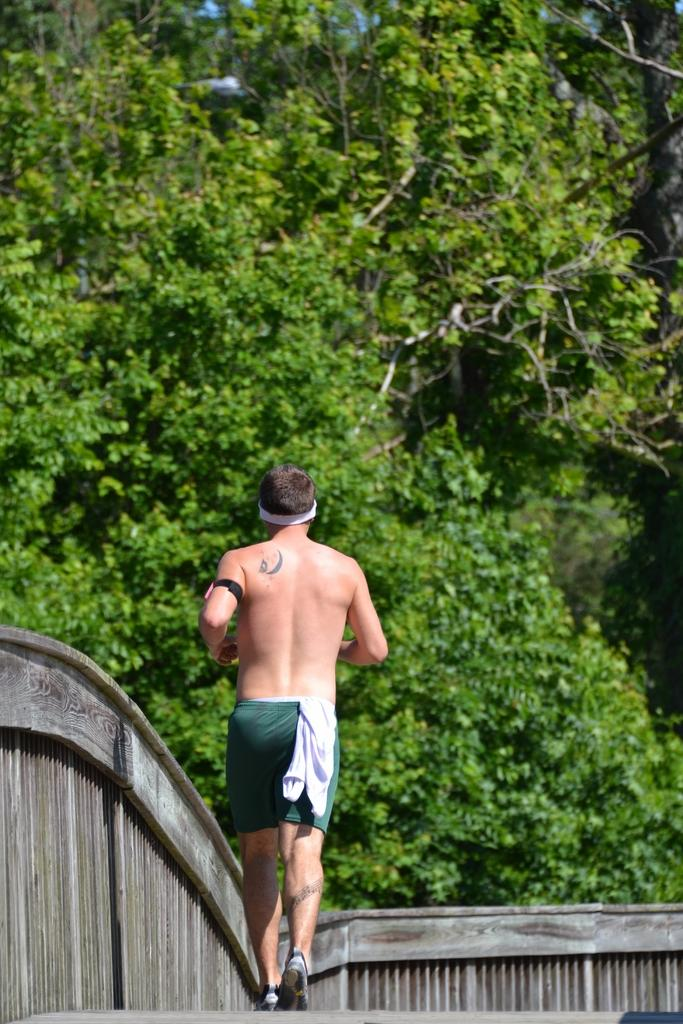What is the main subject of the image? There is a man in the image. What is the man doing in the image? The man is running. On what surface is the man running? The man is running on a wooden plank. What can be seen in the background of the image? There are trees in the background of the image. Where is the bear located in the image? There is no bear present in the image. What type of trail can be seen in the image? There is no trail visible in the image; it features a man running on a wooden plank with trees in the background. 